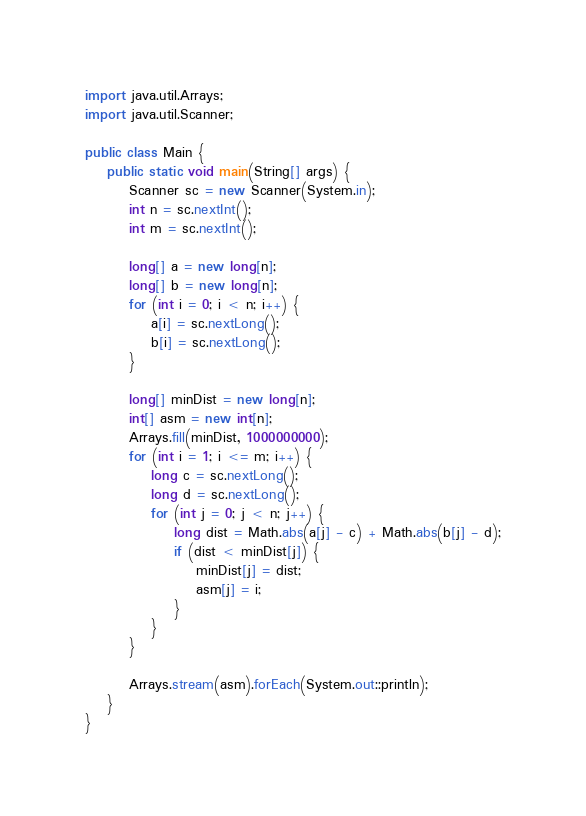Convert code to text. <code><loc_0><loc_0><loc_500><loc_500><_Java_>import java.util.Arrays;
import java.util.Scanner;

public class Main {
	public static void main(String[] args) {
		Scanner sc = new Scanner(System.in);
		int n = sc.nextInt();
		int m = sc.nextInt();
		
		long[] a = new long[n];
		long[] b = new long[n];
		for (int i = 0; i < n; i++) {
			a[i] = sc.nextLong();
			b[i] = sc.nextLong();
		}
		
		long[] minDist = new long[n];
		int[] asm = new int[n];
		Arrays.fill(minDist, 1000000000);
		for (int i = 1; i <= m; i++) {
			long c = sc.nextLong();
			long d = sc.nextLong();
			for (int j = 0; j < n; j++) {
				long dist = Math.abs(a[j] - c) + Math.abs(b[j] - d);
				if (dist < minDist[j]) {
					minDist[j] = dist;
					asm[j] = i;
				}
			}
		}
		
		Arrays.stream(asm).forEach(System.out::println);
	}
}
</code> 